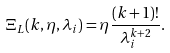<formula> <loc_0><loc_0><loc_500><loc_500>\Xi _ { L } ( k , \eta , \lambda _ { i } ) = \eta \frac { ( k + 1 ) ! } { \lambda _ { i } ^ { k + 2 } } .</formula> 